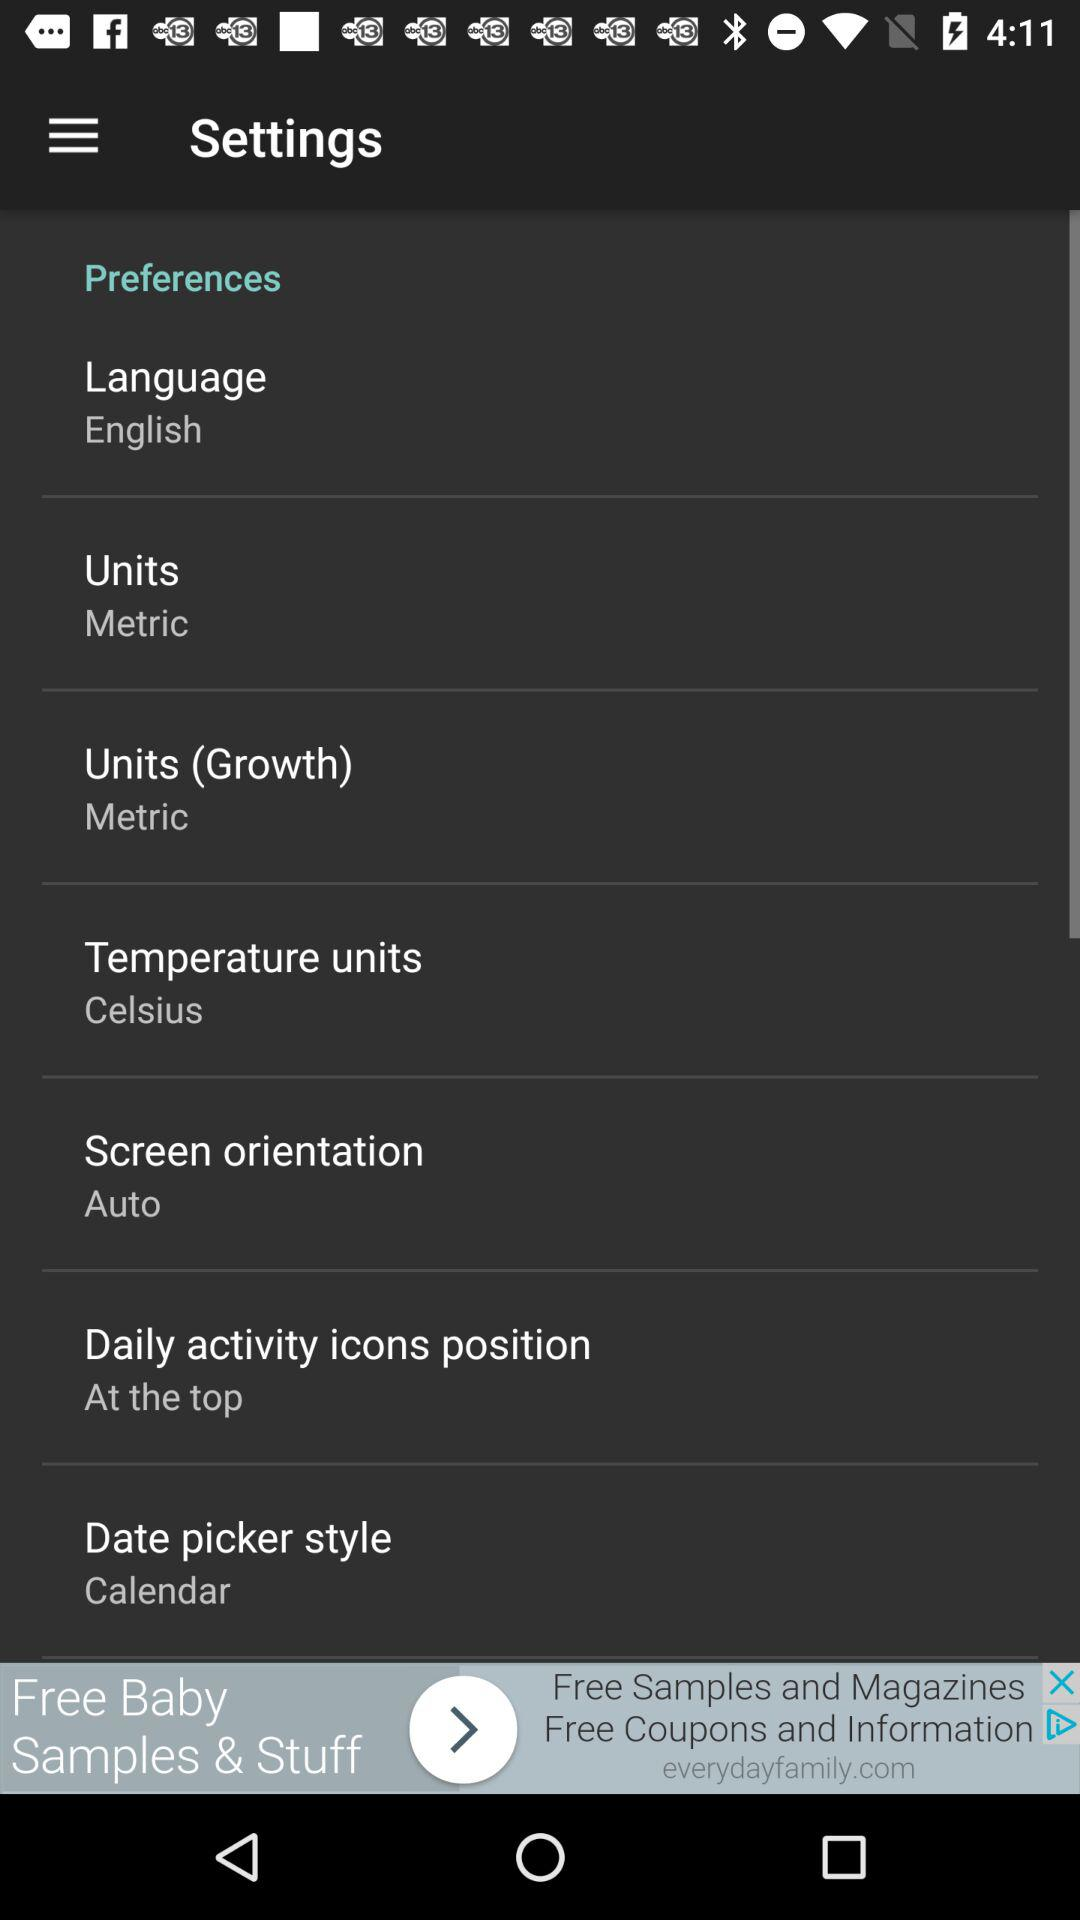What is the screen orientation? The screen orientation is auto. 